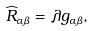Convert formula to latex. <formula><loc_0><loc_0><loc_500><loc_500>\widehat { R } _ { \alpha \beta } = \lambda g _ { \alpha \beta } ,</formula> 